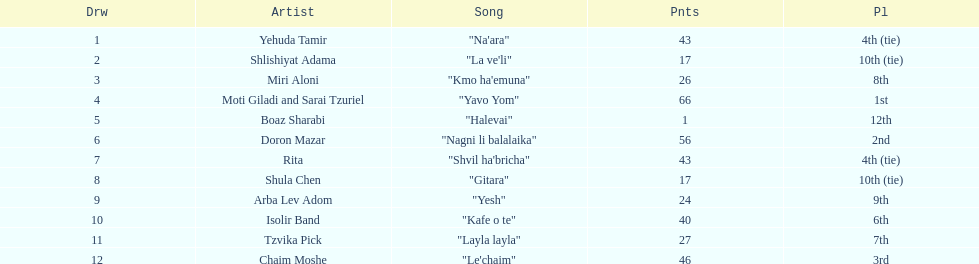What song is listed in the table right before layla layla? "Kafe o te". 